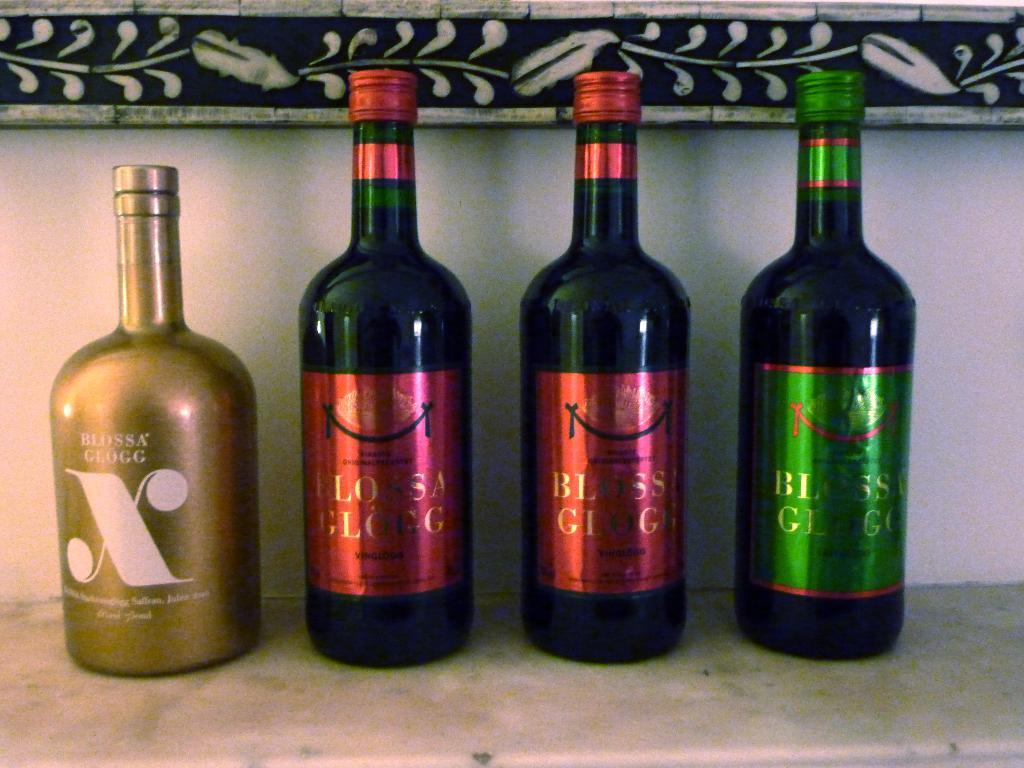<image>
Relay a brief, clear account of the picture shown. Several bottles of alcohol, a gold one on the left has the letter X on it. 